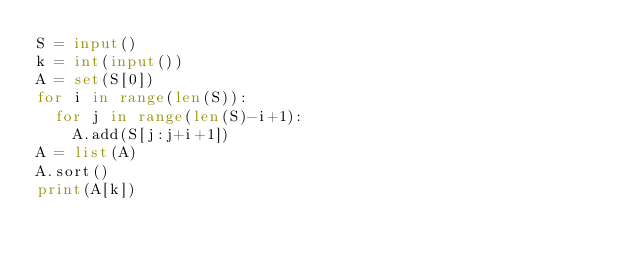<code> <loc_0><loc_0><loc_500><loc_500><_Python_>S = input()
k = int(input())
A = set(S[0])
for i in range(len(S)):
	for j in range(len(S)-i+1):
		A.add(S[j:j+i+1])
A = list(A)
A.sort()
print(A[k])</code> 